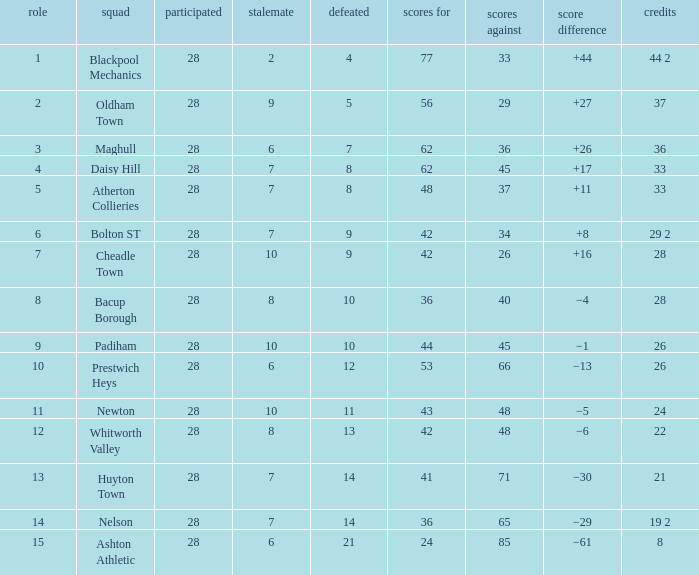What is the lowest drawn for entries with a lost of 13? 8.0. 